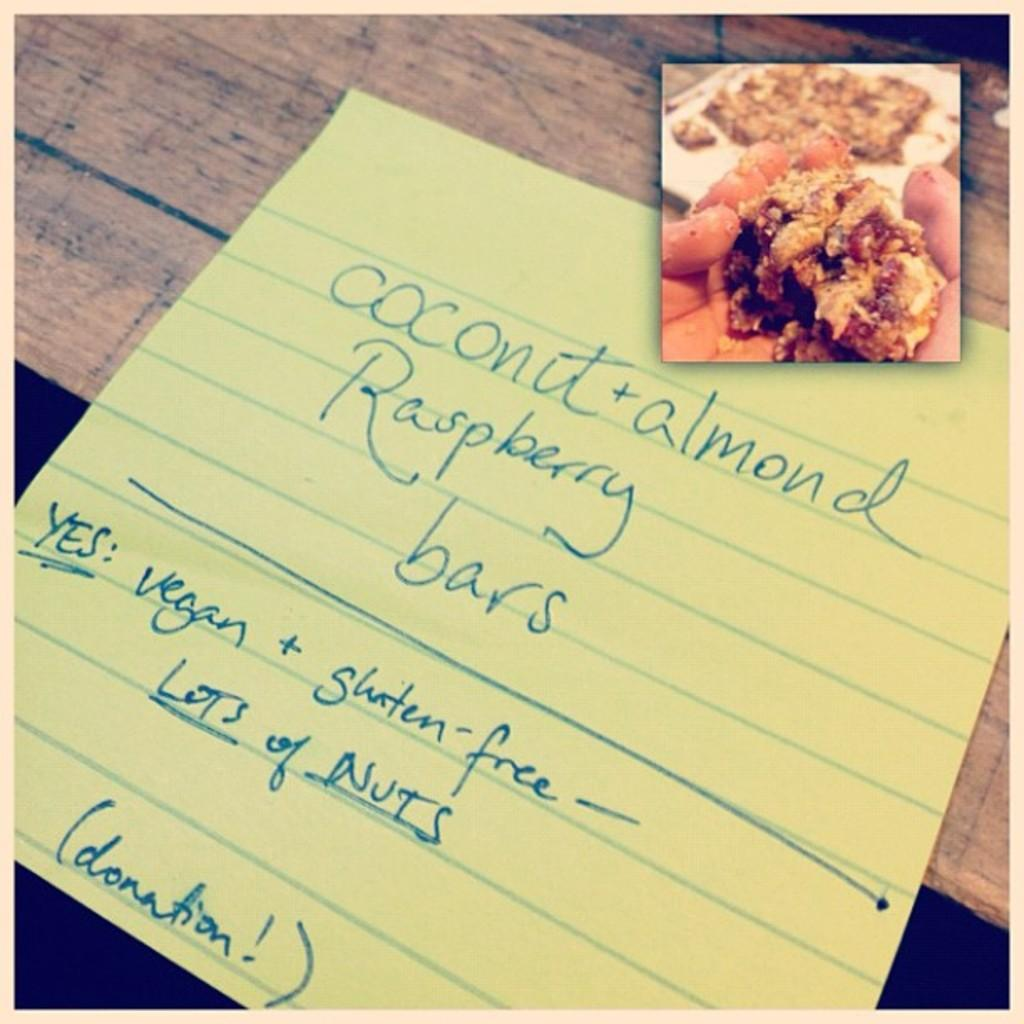What is placed on the wooden surface in the image? There is paper and a board on the wooden surface. Can you describe the board on the wooden surface? The provided facts do not give any details about the board, so we cannot describe it further. How does the boy interact with the paper and board in the image? There is no boy present in the image, so we cannot describe any interaction with the paper and board. 